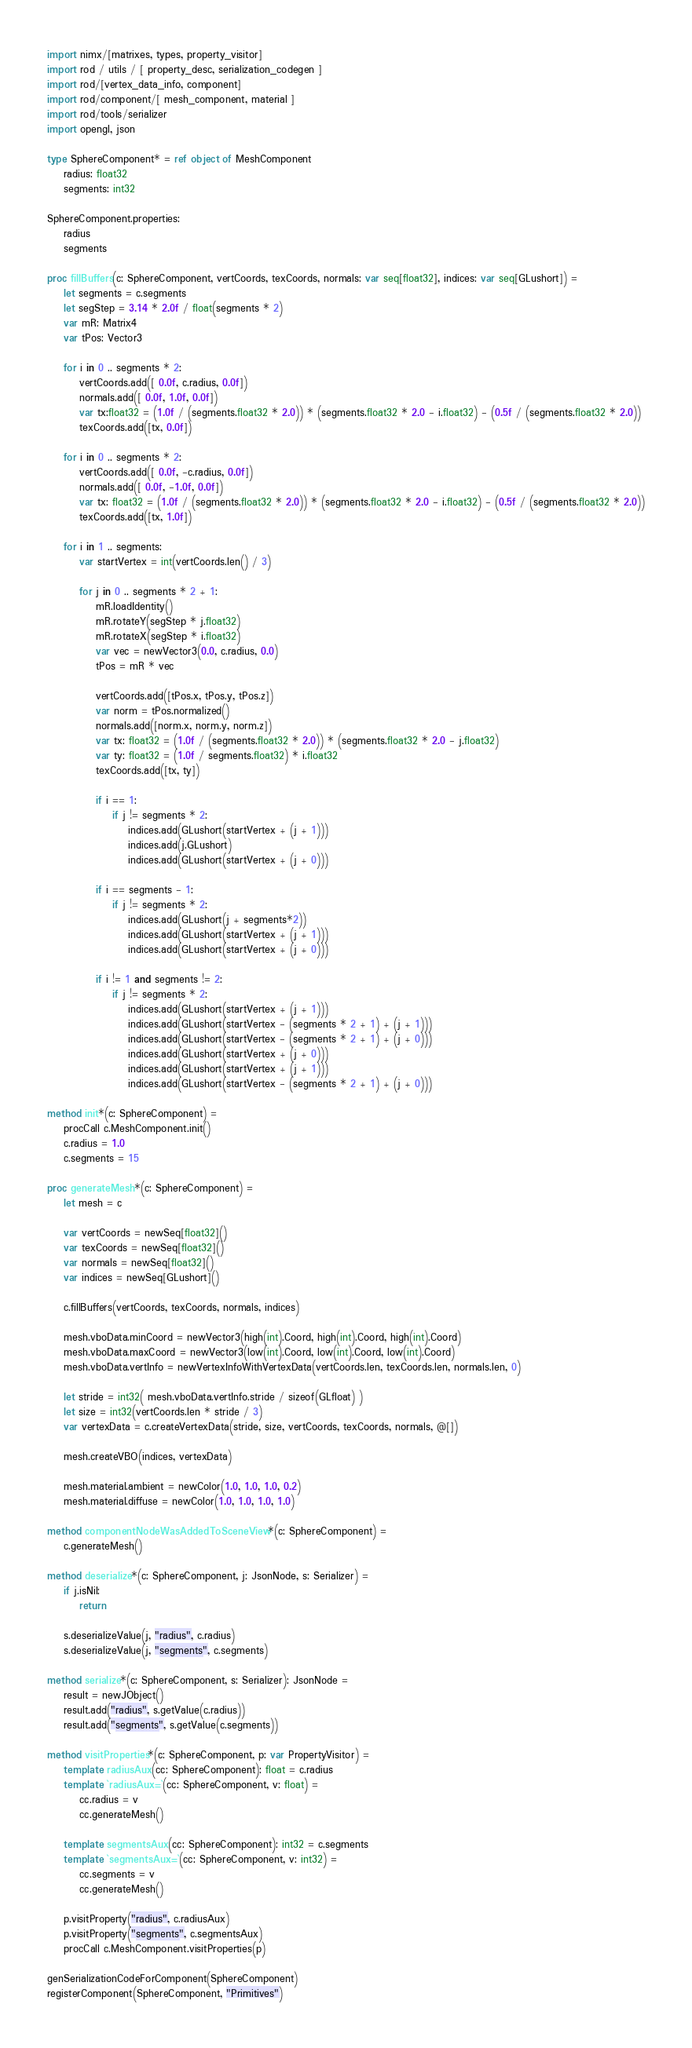Convert code to text. <code><loc_0><loc_0><loc_500><loc_500><_Nim_>import nimx/[matrixes, types, property_visitor]
import rod / utils / [ property_desc, serialization_codegen ]
import rod/[vertex_data_info, component]
import rod/component/[ mesh_component, material ]
import rod/tools/serializer
import opengl, json

type SphereComponent* = ref object of MeshComponent
    radius: float32
    segments: int32

SphereComponent.properties:
    radius
    segments

proc fillBuffers(c: SphereComponent, vertCoords, texCoords, normals: var seq[float32], indices: var seq[GLushort]) =
    let segments = c.segments
    let segStep = 3.14 * 2.0f / float(segments * 2)
    var mR: Matrix4
    var tPos: Vector3

    for i in 0 .. segments * 2:
        vertCoords.add([ 0.0f, c.radius, 0.0f])
        normals.add([ 0.0f, 1.0f, 0.0f])
        var tx:float32 = (1.0f / (segments.float32 * 2.0)) * (segments.float32 * 2.0 - i.float32) - (0.5f / (segments.float32 * 2.0))
        texCoords.add([tx, 0.0f])

    for i in 0 .. segments * 2:
        vertCoords.add([ 0.0f, -c.radius, 0.0f])
        normals.add([ 0.0f, -1.0f, 0.0f])
        var tx: float32 = (1.0f / (segments.float32 * 2.0)) * (segments.float32 * 2.0 - i.float32) - (0.5f / (segments.float32 * 2.0))
        texCoords.add([tx, 1.0f])

    for i in 1 .. segments:
        var startVertex = int(vertCoords.len() / 3)

        for j in 0 .. segments * 2 + 1:
            mR.loadIdentity()
            mR.rotateY(segStep * j.float32)
            mR.rotateX(segStep * i.float32)
            var vec = newVector3(0.0, c.radius, 0.0)
            tPos = mR * vec

            vertCoords.add([tPos.x, tPos.y, tPos.z])
            var norm = tPos.normalized()
            normals.add([norm.x, norm.y, norm.z])
            var tx: float32 = (1.0f / (segments.float32 * 2.0)) * (segments.float32 * 2.0 - j.float32)
            var ty: float32 = (1.0f / segments.float32) * i.float32
            texCoords.add([tx, ty])

            if i == 1:
                if j != segments * 2:
                    indices.add(GLushort(startVertex + (j + 1)))
                    indices.add(j.GLushort)
                    indices.add(GLushort(startVertex + (j + 0)))

            if i == segments - 1:
                if j != segments * 2:
                    indices.add(GLushort(j + segments*2))
                    indices.add(GLushort(startVertex + (j + 1)))
                    indices.add(GLushort(startVertex + (j + 0)))

            if i != 1 and segments != 2:
                if j != segments * 2:
                    indices.add(GLushort(startVertex + (j + 1)))
                    indices.add(GLushort(startVertex - (segments * 2 + 1) + (j + 1)))
                    indices.add(GLushort(startVertex - (segments * 2 + 1) + (j + 0)))
                    indices.add(GLushort(startVertex + (j + 0)))
                    indices.add(GLushort(startVertex + (j + 1)))
                    indices.add(GLushort(startVertex - (segments * 2 + 1) + (j + 0)))

method init*(c: SphereComponent) =
    procCall c.MeshComponent.init()
    c.radius = 1.0
    c.segments = 15

proc generateMesh*(c: SphereComponent) =
    let mesh = c

    var vertCoords = newSeq[float32]()
    var texCoords = newSeq[float32]()
    var normals = newSeq[float32]()
    var indices = newSeq[GLushort]()

    c.fillBuffers(vertCoords, texCoords, normals, indices)

    mesh.vboData.minCoord = newVector3(high(int).Coord, high(int).Coord, high(int).Coord)
    mesh.vboData.maxCoord = newVector3(low(int).Coord, low(int).Coord, low(int).Coord)
    mesh.vboData.vertInfo = newVertexInfoWithVertexData(vertCoords.len, texCoords.len, normals.len, 0)

    let stride = int32( mesh.vboData.vertInfo.stride / sizeof(GLfloat) )
    let size = int32(vertCoords.len * stride / 3)
    var vertexData = c.createVertexData(stride, size, vertCoords, texCoords, normals, @[])

    mesh.createVBO(indices, vertexData)

    mesh.material.ambient = newColor(1.0, 1.0, 1.0, 0.2)
    mesh.material.diffuse = newColor(1.0, 1.0, 1.0, 1.0)

method componentNodeWasAddedToSceneView*(c: SphereComponent) =
    c.generateMesh()

method deserialize*(c: SphereComponent, j: JsonNode, s: Serializer) =
    if j.isNil:
        return

    s.deserializeValue(j, "radius", c.radius)
    s.deserializeValue(j, "segments", c.segments)

method serialize*(c: SphereComponent, s: Serializer): JsonNode =
    result = newJObject()
    result.add("radius", s.getValue(c.radius))
    result.add("segments", s.getValue(c.segments))

method visitProperties*(c: SphereComponent, p: var PropertyVisitor) =
    template radiusAux(cc: SphereComponent): float = c.radius
    template `radiusAux=`(cc: SphereComponent, v: float) =
        cc.radius = v
        cc.generateMesh()

    template segmentsAux(cc: SphereComponent): int32 = c.segments
    template `segmentsAux=`(cc: SphereComponent, v: int32) =
        cc.segments = v
        cc.generateMesh()

    p.visitProperty("radius", c.radiusAux)
    p.visitProperty("segments", c.segmentsAux)
    procCall c.MeshComponent.visitProperties(p)

genSerializationCodeForComponent(SphereComponent)
registerComponent(SphereComponent, "Primitives")
</code> 